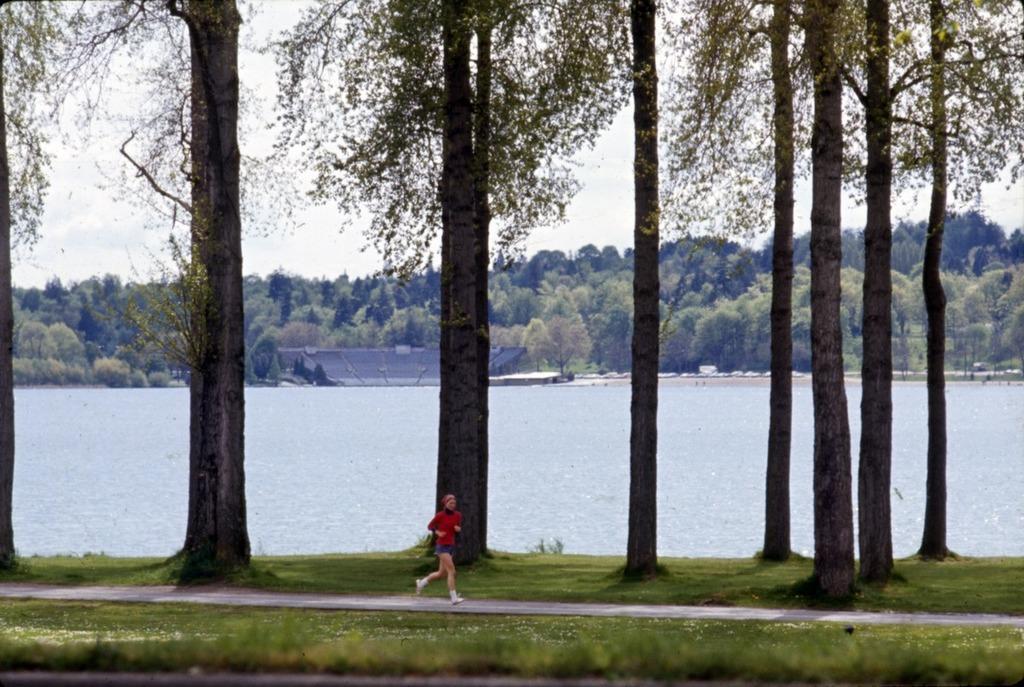How would you summarize this image in a sentence or two? In the image there is a person running on road with grassland either side of and trees behind it, in the back there is a lake followed by many trees in the background and above its sky. 